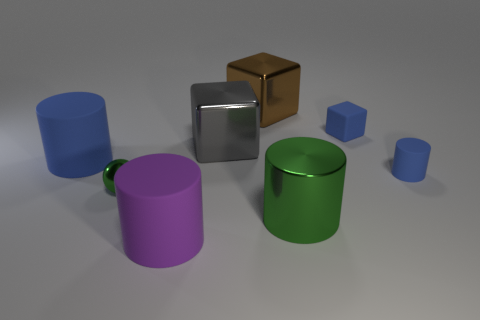There is a big cylinder that is to the right of the small green thing and behind the purple cylinder; what is its color? The big cylinder situated to the right of the small green object and behind the purple cylinder is blue in color. 